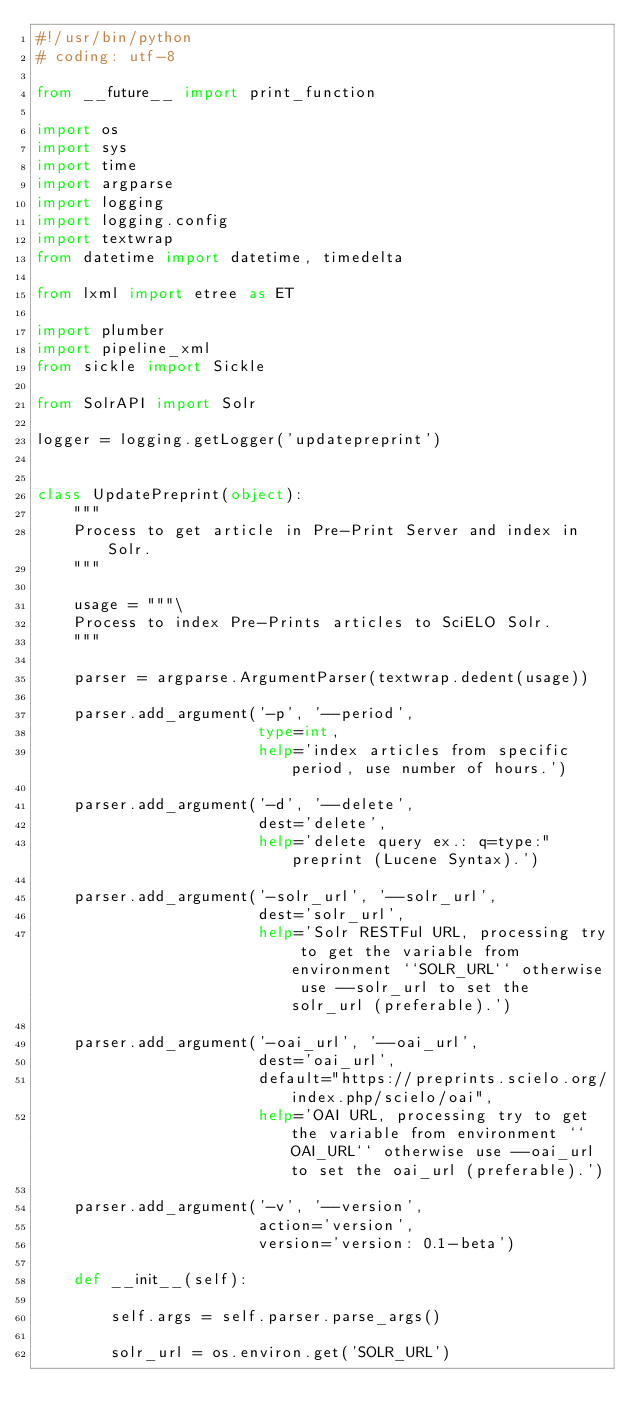Convert code to text. <code><loc_0><loc_0><loc_500><loc_500><_Python_>#!/usr/bin/python
# coding: utf-8

from __future__ import print_function

import os
import sys
import time
import argparse
import logging
import logging.config
import textwrap
from datetime import datetime, timedelta

from lxml import etree as ET

import plumber
import pipeline_xml
from sickle import Sickle

from SolrAPI import Solr

logger = logging.getLogger('updatepreprint')


class UpdatePreprint(object):
    """
    Process to get article in Pre-Print Server and index in Solr.
    """

    usage = """\
    Process to index Pre-Prints articles to SciELO Solr.
    """

    parser = argparse.ArgumentParser(textwrap.dedent(usage))

    parser.add_argument('-p', '--period',
                        type=int,
                        help='index articles from specific period, use number of hours.')

    parser.add_argument('-d', '--delete',
                        dest='delete',
                        help='delete query ex.: q=type:"preprint (Lucene Syntax).')

    parser.add_argument('-solr_url', '--solr_url',
                        dest='solr_url',
                        help='Solr RESTFul URL, processing try to get the variable from environment ``SOLR_URL`` otherwise use --solr_url to set the solr_url (preferable).')

    parser.add_argument('-oai_url', '--oai_url',
                        dest='oai_url',
                        default="https://preprints.scielo.org/index.php/scielo/oai",
                        help='OAI URL, processing try to get the variable from environment ``OAI_URL`` otherwise use --oai_url to set the oai_url (preferable).')

    parser.add_argument('-v', '--version',
                        action='version',
                        version='version: 0.1-beta')

    def __init__(self):

        self.args = self.parser.parse_args()

        solr_url = os.environ.get('SOLR_URL')</code> 